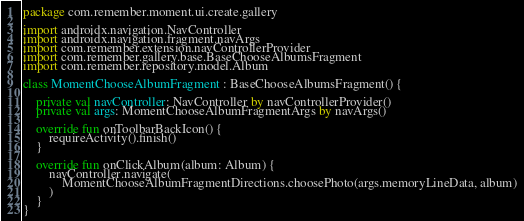<code> <loc_0><loc_0><loc_500><loc_500><_Kotlin_>package com.remember.moment.ui.create.gallery

import androidx.navigation.NavController
import androidx.navigation.fragment.navArgs
import com.remember.extension.navControllerProvider
import com.remember.gallery.base.BaseChooseAlbumsFragment
import com.remember.repository.model.Album

class MomentChooseAlbumFragment : BaseChooseAlbumsFragment() {

    private val navController: NavController by navControllerProvider()
    private val args: MomentChooseAlbumFragmentArgs by navArgs()

    override fun onToolbarBackIcon() {
        requireActivity().finish()
    }

    override fun onClickAlbum(album: Album) {
        navController.navigate(
            MomentChooseAlbumFragmentDirections.choosePhoto(args.memoryLineData, album)
        )
    }
}
</code> 